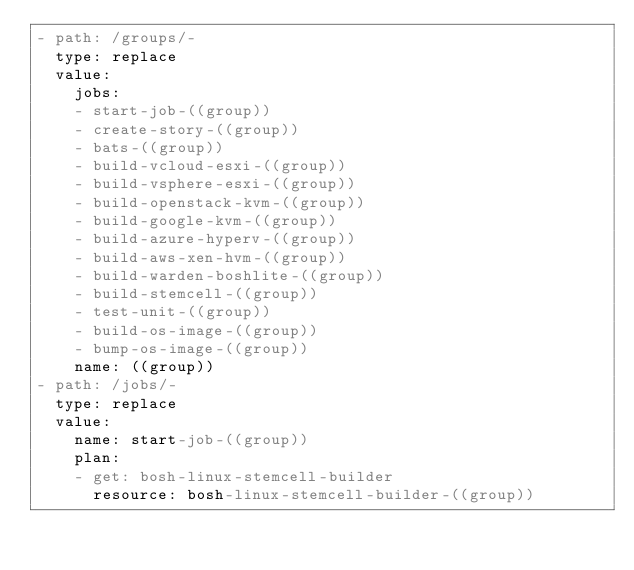<code> <loc_0><loc_0><loc_500><loc_500><_YAML_>- path: /groups/-
  type: replace
  value:
    jobs:
    - start-job-((group))
    - create-story-((group))
    - bats-((group))
    - build-vcloud-esxi-((group))
    - build-vsphere-esxi-((group))
    - build-openstack-kvm-((group))
    - build-google-kvm-((group))
    - build-azure-hyperv-((group))
    - build-aws-xen-hvm-((group))
    - build-warden-boshlite-((group))
    - build-stemcell-((group))
    - test-unit-((group))
    - build-os-image-((group))
    - bump-os-image-((group))
    name: ((group))
- path: /jobs/-
  type: replace
  value:
    name: start-job-((group))
    plan:
    - get: bosh-linux-stemcell-builder
      resource: bosh-linux-stemcell-builder-((group))</code> 